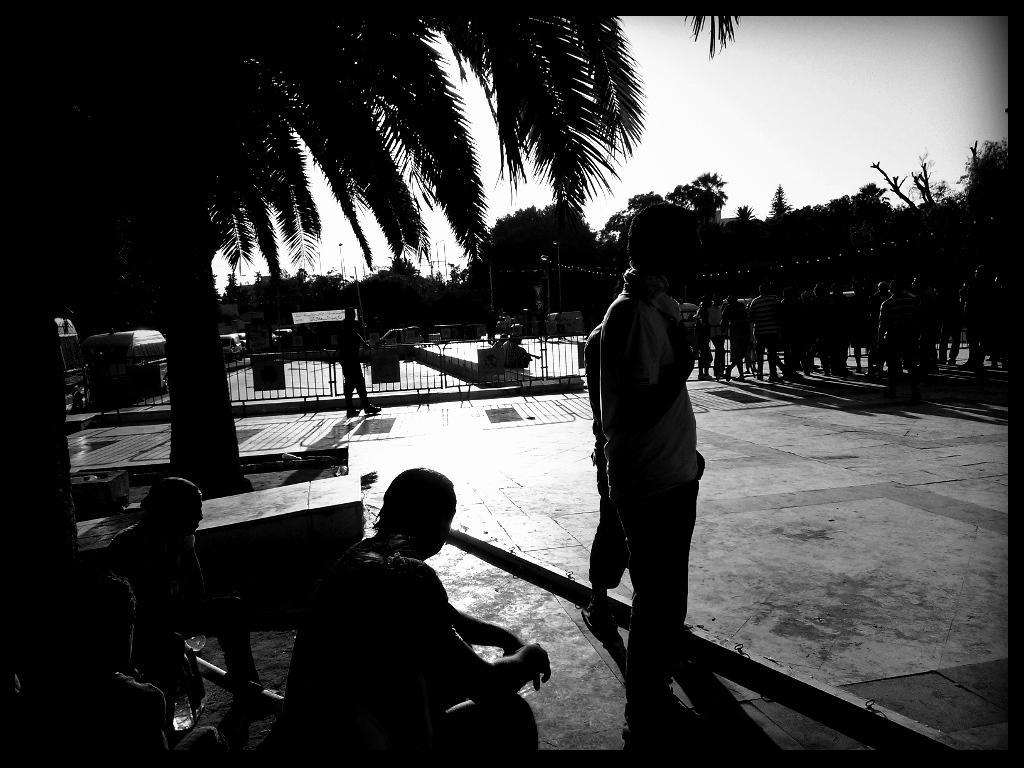Please provide a concise description of this image. In this image we can see some persons sitting and some persons standing on the floor. In the background we can see iron grills, street poles, street lights, motor vehicles, trees and sky. 